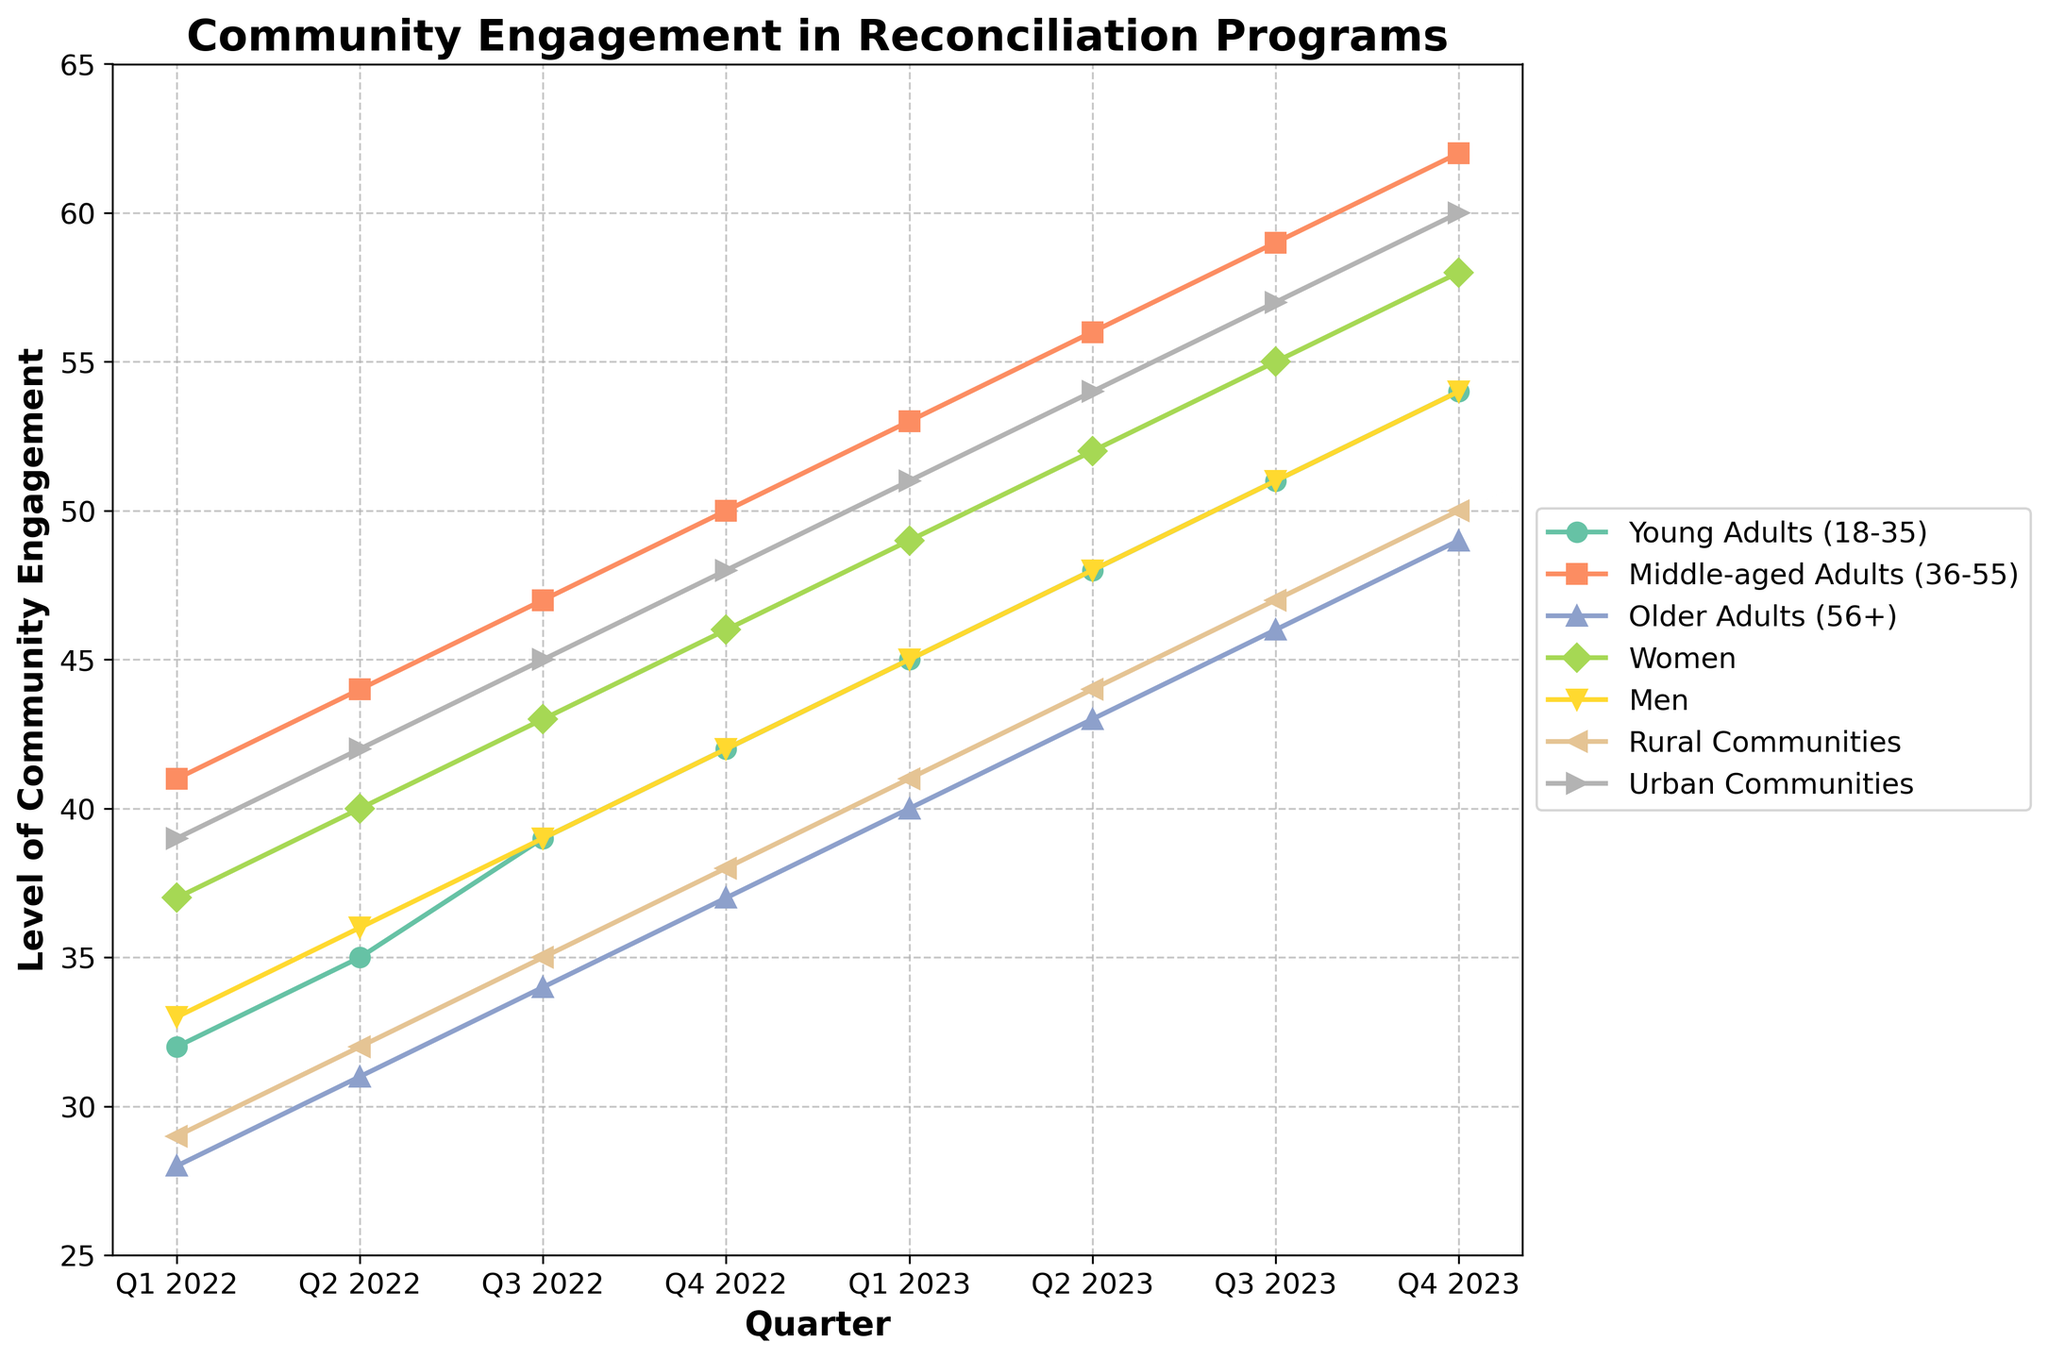what's the difference in community engagement between Young Adults and Middle-aged Adults in Q4 2023? The value for Young Adults in Q4 2023 is 54, and for Middle-aged Adults, it is 62. The difference is calculated as 62 - 54 = 8
Answer: 8 which group had the highest community engagement in Q2 2022? Referring to Q2 2022, the values are: Young Adults (35), Middle-aged Adults (44), Older Adults (31), Women (40), Men (36), Rural Communities (32), Urban Communities (42). The highest value is 44 for Middle-aged Adults.
Answer: Middle-aged Adults what was the trend of community engagement for Rural Communities from Q1 2022 to Q4 2023? Observing the values for Rural Communities: Q1 2022 (29), Q2 2022 (32), Q3 2022 (35), Q4 2022 (38), Q1 2023 (41), Q2 2023 (44), Q3 2023 (47), Q4 2023 (50). The trend shows a steady increase every quarter.
Answer: steady increase what is the average community engagement level for Women across all quarters? Adding the values for Women: 37 + 40 + 43 + 46 + 49 + 52 + 55 + 58 = 380. Dividing by the number of quarters: 380 / 8 = 47.5
Answer: 47.5 which demographic group had a close community engagement level to Men in Q3 2023? In Q3 2023, Men had a value of 51. Closest values for comparison: Young Adults (51), Middle-aged Adults (59), Older Adults (46), Women (55), Rural Communities (47), Urban Communities (57). The closest is Young Adults with 51.
Answer: Young Adults was the community engagement for Urban Communities higher or lower than Women in Q1 2023? In Q1 2023, Urban Communities had a value of 51 and Women had 49. Since 51 > 49, Urban Communities engagement was higher.
Answer: higher what is the overall change in community engagement for Older Adults from Q1 2022 to Q4 2023? Older Adults in Q1 2022 had a value of 28 and in Q4 2023 had 49. The change is 49 - 28 = 21.
Answer: 21 among all demographic groups, which consistently improved every quarter without any drop? By observing each group's trend from Q1 2022 to Q4 2023, all groups consistently increased their engagement each quarter.
Answer: All groups in Q4 2022, how did the level of community engagement compare between Rural and Urban Communities? In Q4 2022, Rural Communities had 38, and Urban Communities had 48. Comparing the two, Urban Communities had a higher engagement by 48 - 38 = 10.
Answer: Urban Communities what is the cumulative increase in community engagement for Middle-aged Adults from Q1 2022 to Q4 2023? The values for Middle-aged Adults: Q1 2022 (41), Q2 2022 (44), Q3 2022 (47), Q4 2022 (50), Q1 2023 (53), Q2 2023 (56), Q3 2023 (59), Q4 2023 (62). The cumulative increase is 62 - 41 = 21.
Answer: 21 